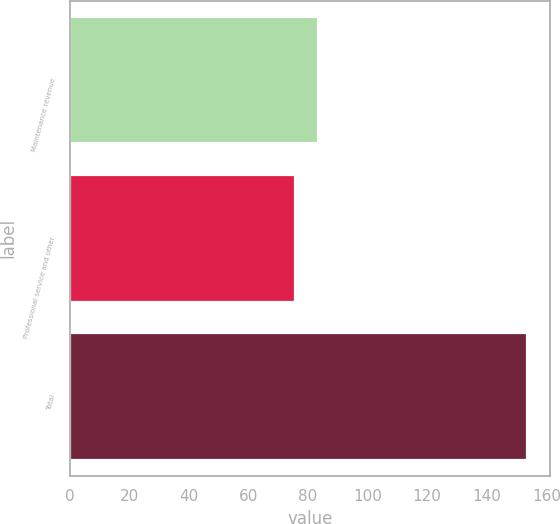Convert chart to OTSL. <chart><loc_0><loc_0><loc_500><loc_500><bar_chart><fcel>Maintenance revenue<fcel>Professional service and other<fcel>Total<nl><fcel>83.31<fcel>75.5<fcel>153.6<nl></chart> 